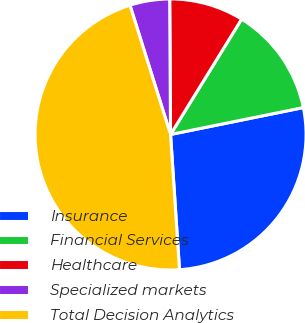Convert chart. <chart><loc_0><loc_0><loc_500><loc_500><pie_chart><fcel>Insurance<fcel>Financial Services<fcel>Healthcare<fcel>Specialized markets<fcel>Total Decision Analytics<nl><fcel>27.13%<fcel>13.03%<fcel>8.89%<fcel>4.74%<fcel>46.21%<nl></chart> 